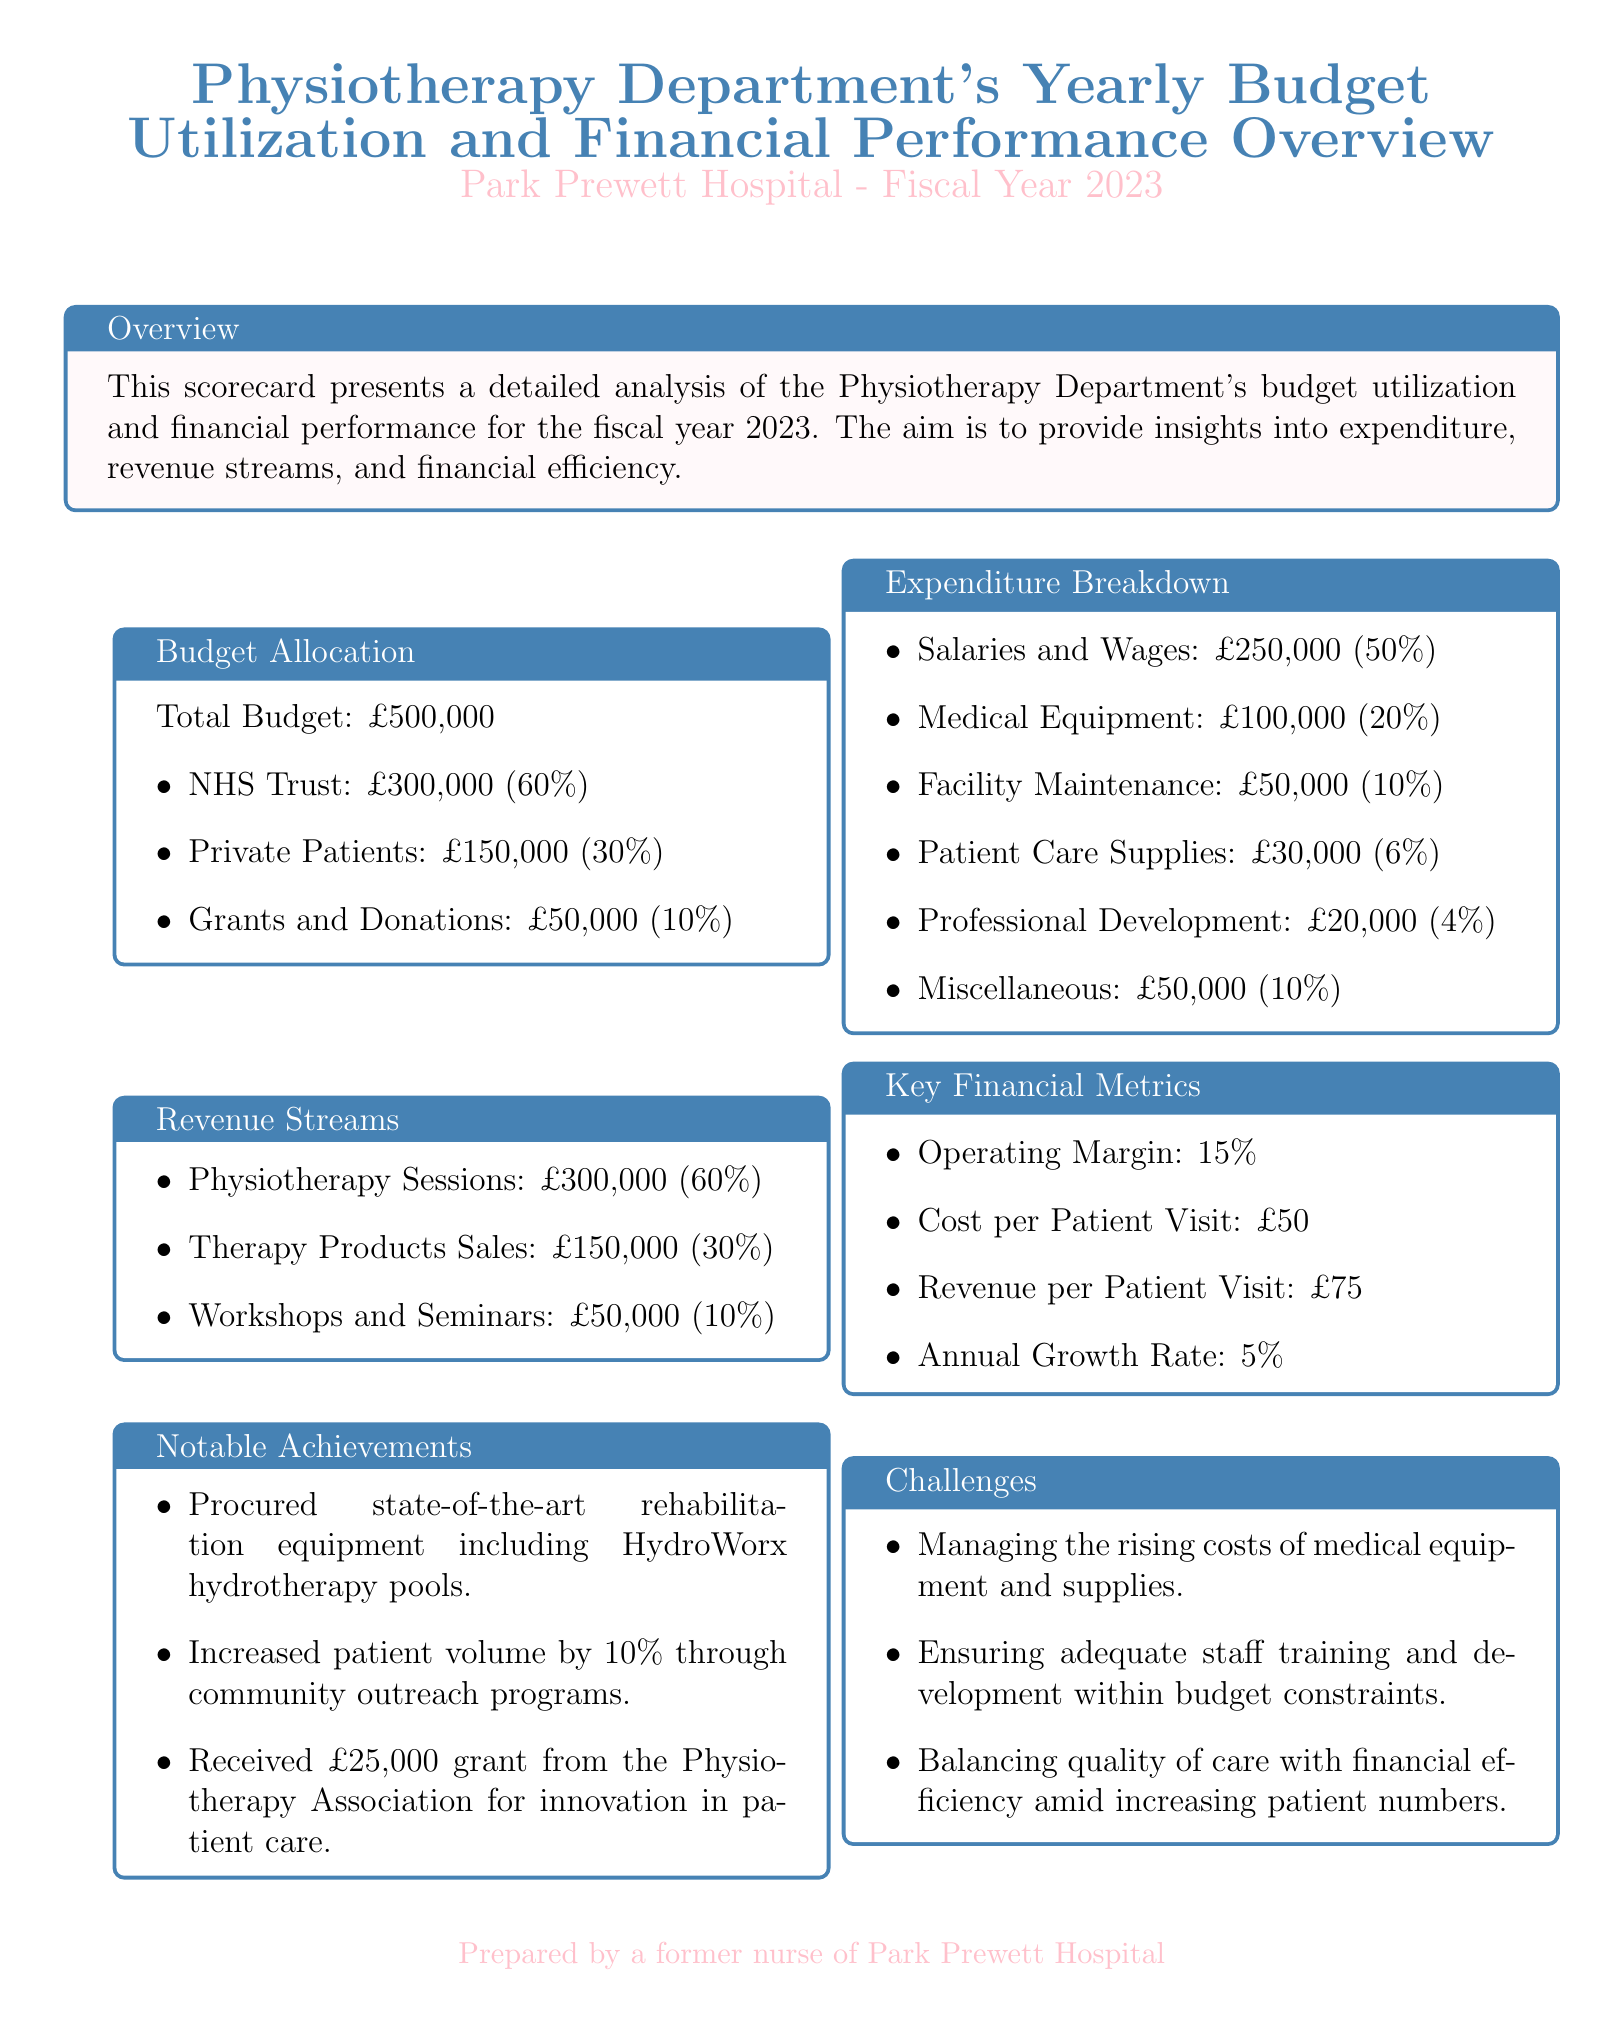what is the total budget for the Physiotherapy Department? The total budget is explicitly stated in the document under "Budget Allocation."
Answer: £500,000 how much of the budget comes from NHS Trust? The budget allocation details the distribution among sources, where NHS Trust is specifically mentioned.
Answer: £300,000 what percentage of the total budget is allocated to Grants and Donations? The budget allocation section provides the percentage distribution of the total budget to each source.
Answer: 10% what is the cost per patient visit? This information is found in the Key Financial Metrics section of the document.
Answer: £50 what was the annual growth rate for the Physiotherapy Department? The Key Financial Metrics section specifies the annual growth rate.
Answer: 5% how much was spent on Medical Equipment? The Expenditure Breakdown lists the specific amounts for each category of expenses, including Medical Equipment.
Answer: £100,000 what notable achievement involved a grant? The Notable Achievements section mentions a specific achievement related to a financial grant received.
Answer: received £25,000 grant what challenge relates to staff training? The Challenges section outlines several challenges, one of which specifically addresses staff training.
Answer: ensuring adequate staff training and development which revenue stream contributed the least amount? The Revenue Streams section details each source, allowing for an easy identification of the least contributing stream.
Answer: Workshops and Seminars 